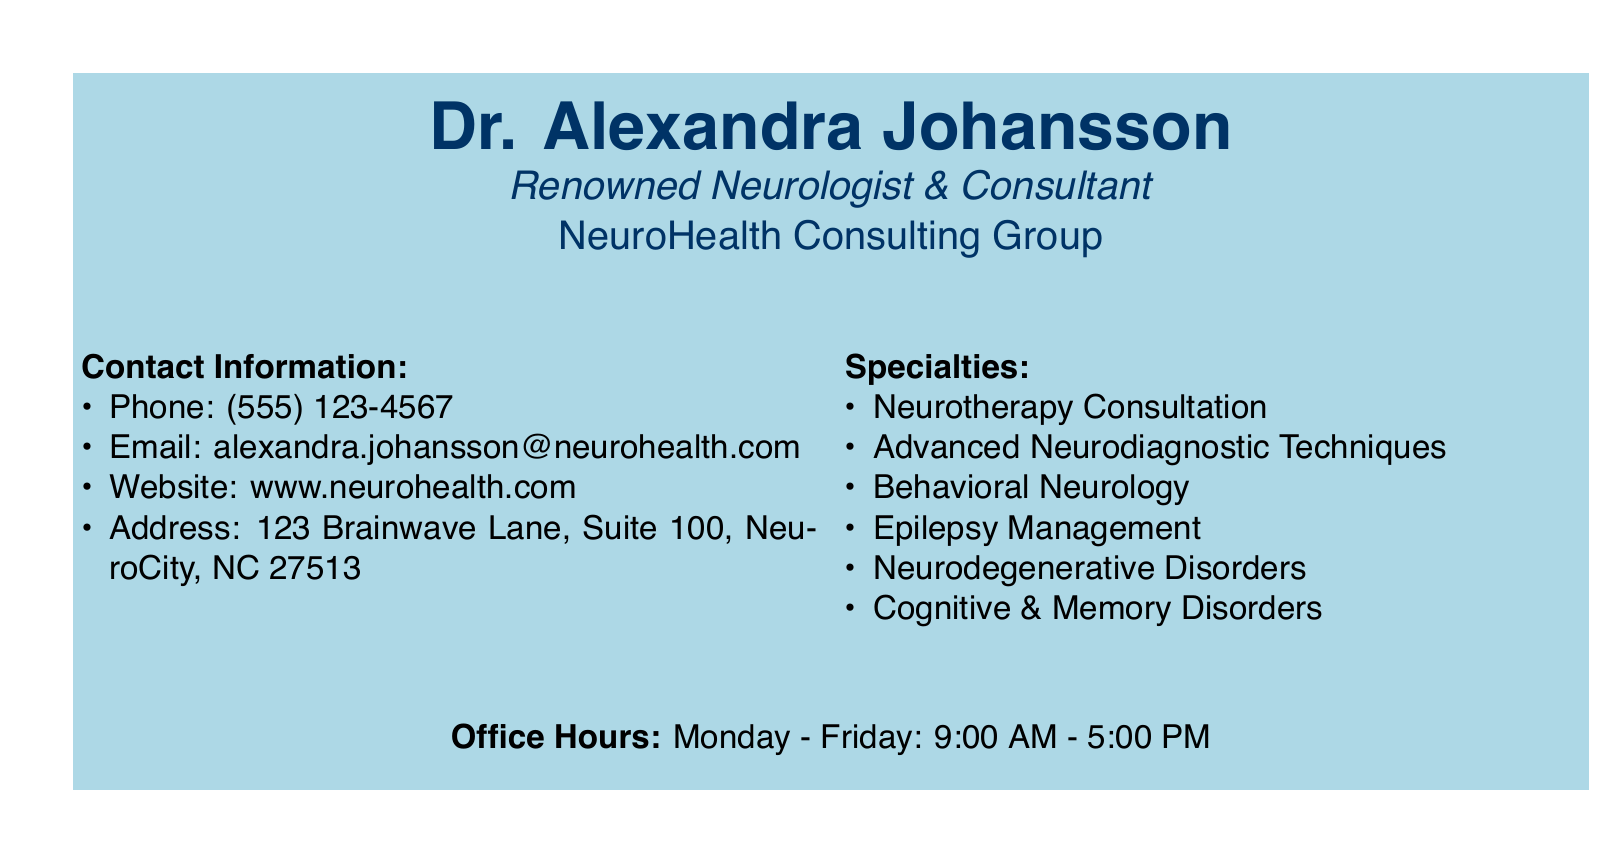What is the name of the neurologist? The name of the neurologist is prominently displayed at the top of the document as Dr. Alexandra Johansson.
Answer: Dr. Alexandra Johansson What is the phone number for contact? The phone number is listed in the contact information section of the document.
Answer: (555) 123-4567 What is the email address provided? The email address is included under the contact information.
Answer: alexandra.johansson@neurohealth.com What is one of the specialties listed? One of the specialties is found in the specialties section of the document.
Answer: Neurotherapy Consultation What are the office hours? The office hours are provided at the bottom of the document.
Answer: Monday - Friday: 9:00 AM - 5:00 PM Which organization is the neurologist affiliated with? The organization is mentioned directly below the neurologist's title.
Answer: NeuroHealth Consulting Group What is the address given on the card? The address is clearly stated under the contact information.
Answer: 123 Brainwave Lane, Suite 100, NeuroCity, NC 27513 What type of document is this? This document presents specific professional information in a compact format typical for networking.
Answer: Business card What area of expertise can be associated with epilepsy? Epilepsy management is a specialty listed, indicating a focus in this area.
Answer: Epilepsy Management What design element is used for the background? The document features a color background to enhance visual appeal, which is indicated in the code.
Answer: Light blue color box 